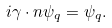Convert formula to latex. <formula><loc_0><loc_0><loc_500><loc_500>i \gamma \cdot n \psi _ { q } = \psi _ { q } .</formula> 